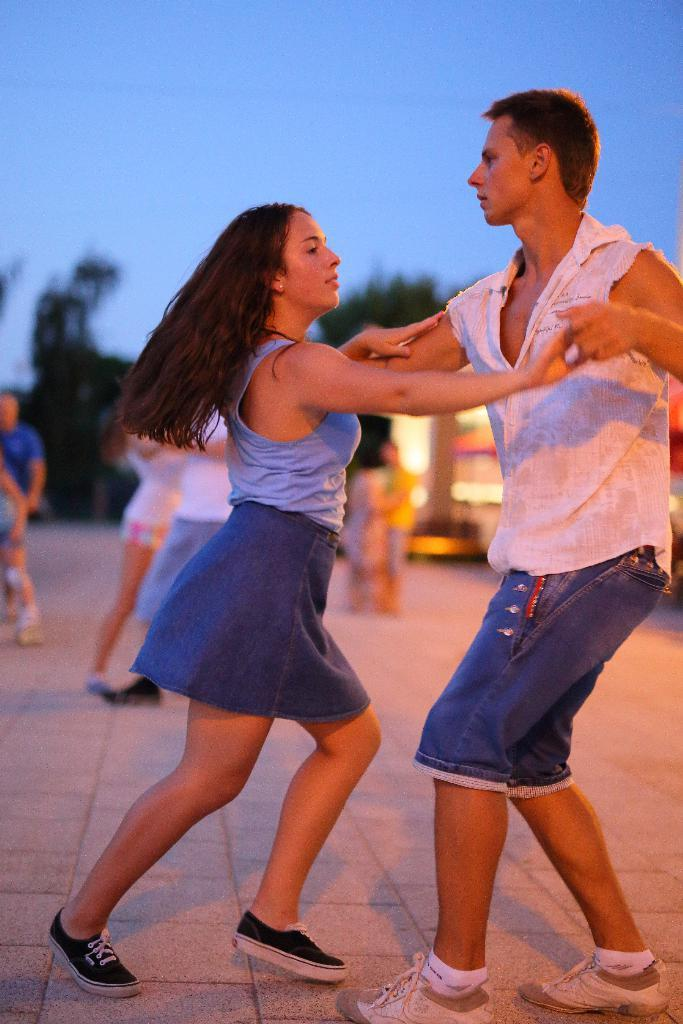What are the persons in the image doing? The persons in the image are dancing. Where are the persons dancing? The persons are dancing on the floor. What can be seen in the background of the image? There are trees visible in the background of the image. What is visible at the top of the image? The sky is visible at the top of the image. How many divisions can be seen in the image? There is no mention of divisions in the image; it features persons dancing on the floor with trees and the sky visible in the background. What type of leg is being used for dancing in the image? There is no specific type of leg being used for dancing in the image; the persons are simply dancing on the floor. 